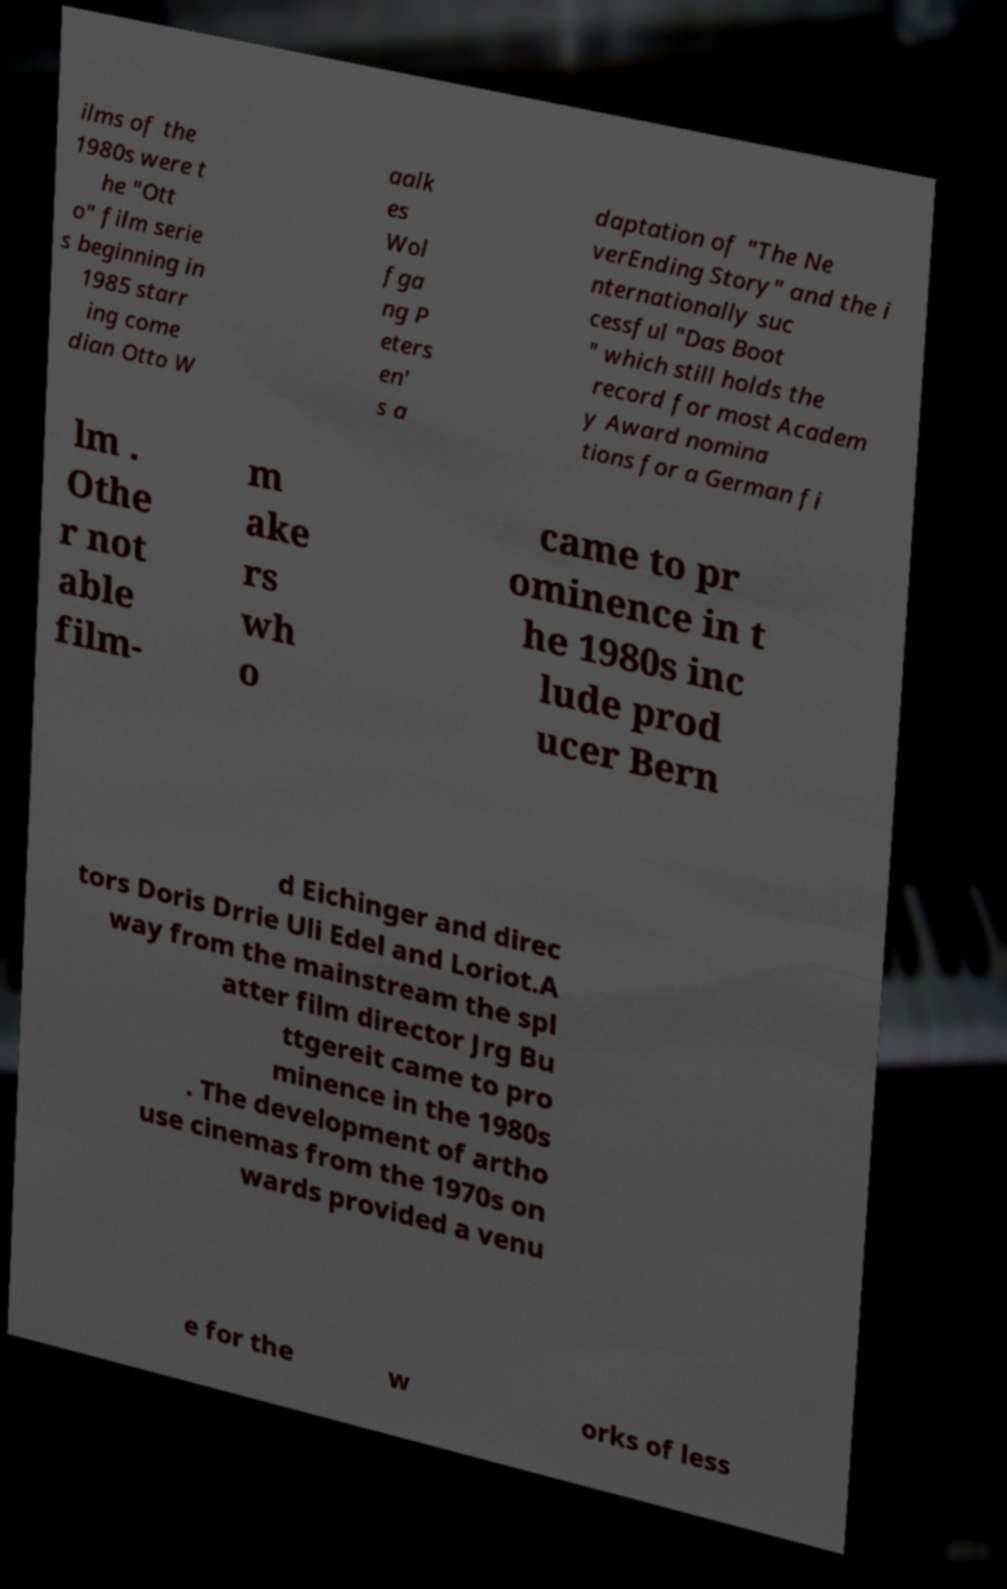Please read and relay the text visible in this image. What does it say? ilms of the 1980s were t he "Ott o" film serie s beginning in 1985 starr ing come dian Otto W aalk es Wol fga ng P eters en' s a daptation of "The Ne verEnding Story" and the i nternationally suc cessful "Das Boot " which still holds the record for most Academ y Award nomina tions for a German fi lm . Othe r not able film- m ake rs wh o came to pr ominence in t he 1980s inc lude prod ucer Bern d Eichinger and direc tors Doris Drrie Uli Edel and Loriot.A way from the mainstream the spl atter film director Jrg Bu ttgereit came to pro minence in the 1980s . The development of artho use cinemas from the 1970s on wards provided a venu e for the w orks of less 